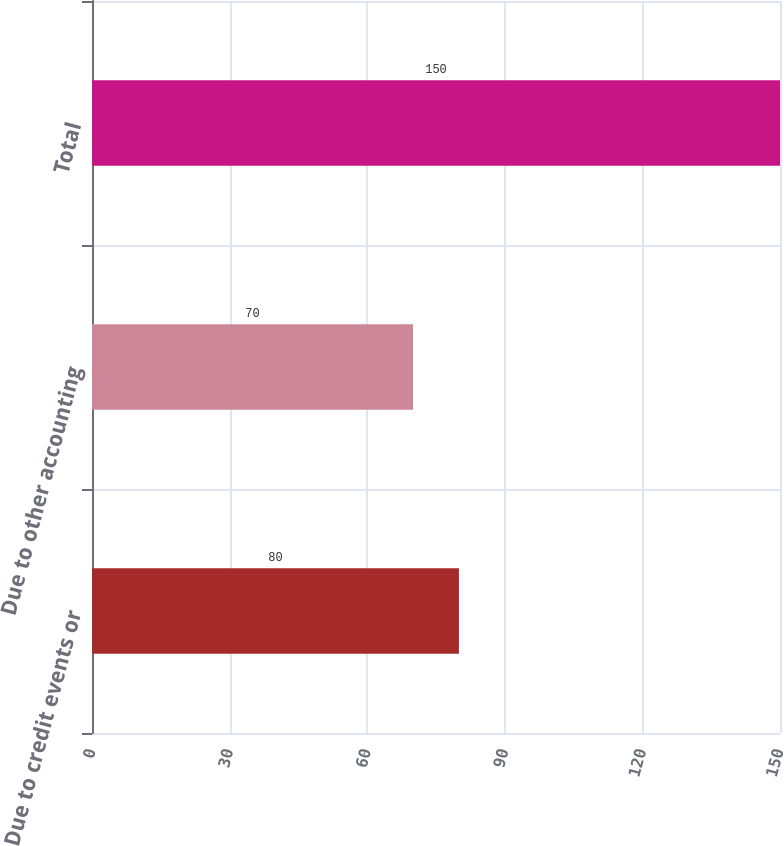Convert chart to OTSL. <chart><loc_0><loc_0><loc_500><loc_500><bar_chart><fcel>Due to credit events or<fcel>Due to other accounting<fcel>Total<nl><fcel>80<fcel>70<fcel>150<nl></chart> 